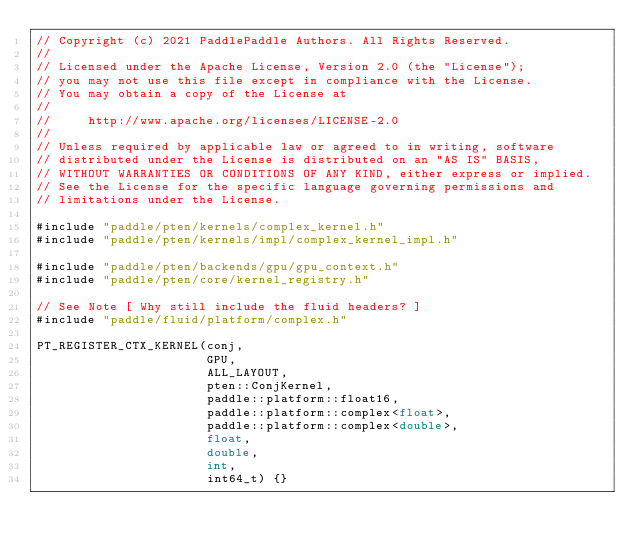Convert code to text. <code><loc_0><loc_0><loc_500><loc_500><_Cuda_>// Copyright (c) 2021 PaddlePaddle Authors. All Rights Reserved.
//
// Licensed under the Apache License, Version 2.0 (the "License");
// you may not use this file except in compliance with the License.
// You may obtain a copy of the License at
//
//     http://www.apache.org/licenses/LICENSE-2.0
//
// Unless required by applicable law or agreed to in writing, software
// distributed under the License is distributed on an "AS IS" BASIS,
// WITHOUT WARRANTIES OR CONDITIONS OF ANY KIND, either express or implied.
// See the License for the specific language governing permissions and
// limitations under the License.

#include "paddle/pten/kernels/complex_kernel.h"
#include "paddle/pten/kernels/impl/complex_kernel_impl.h"

#include "paddle/pten/backends/gpu/gpu_context.h"
#include "paddle/pten/core/kernel_registry.h"

// See Note [ Why still include the fluid headers? ]
#include "paddle/fluid/platform/complex.h"

PT_REGISTER_CTX_KERNEL(conj,
                       GPU,
                       ALL_LAYOUT,
                       pten::ConjKernel,
                       paddle::platform::float16,
                       paddle::platform::complex<float>,
                       paddle::platform::complex<double>,
                       float,
                       double,
                       int,
                       int64_t) {}
</code> 